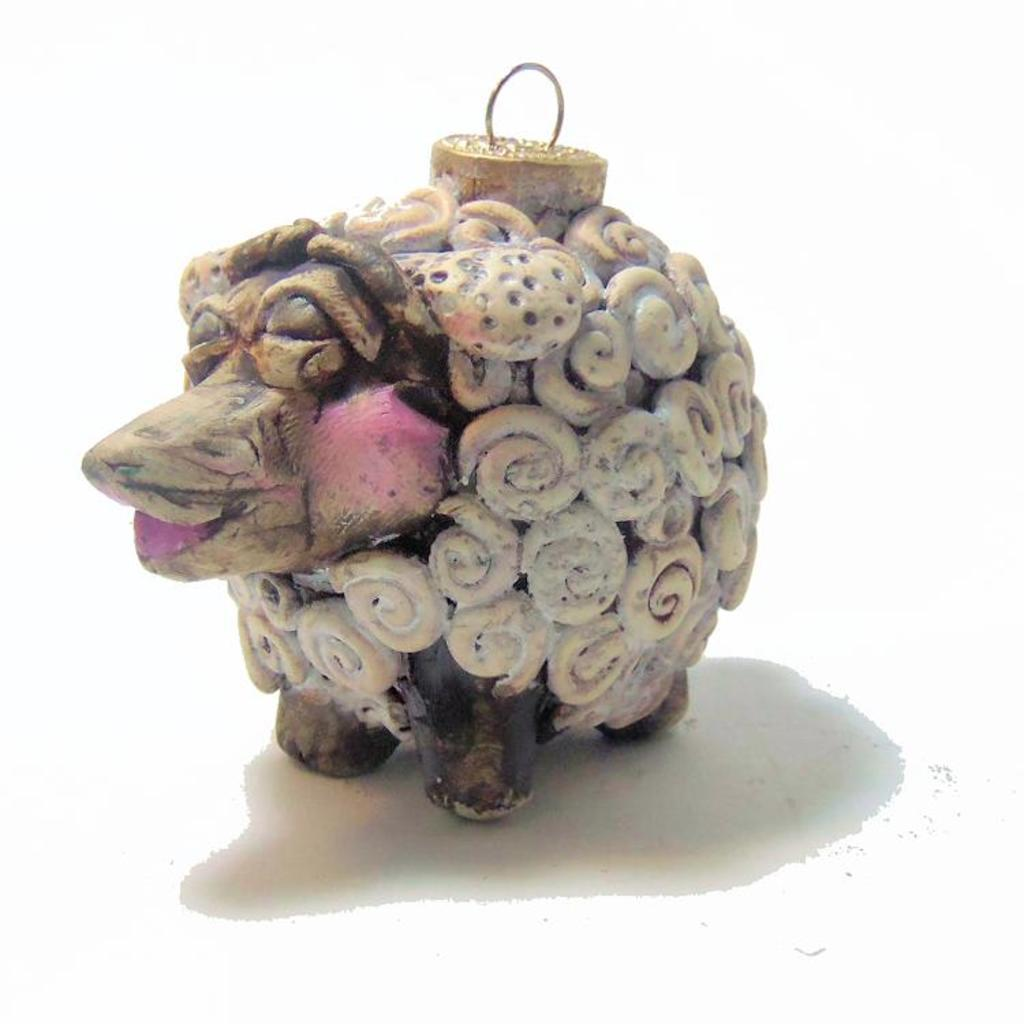What object in the image is designed for play or entertainment? There is a toy in the image. Who is the expert in the image? There is no expert present in the image; it only features a toy. What type of power is being generated by the toy in the image? The toy in the image is not generating any power, as it is likely an inanimate object designed for play or entertainment. 